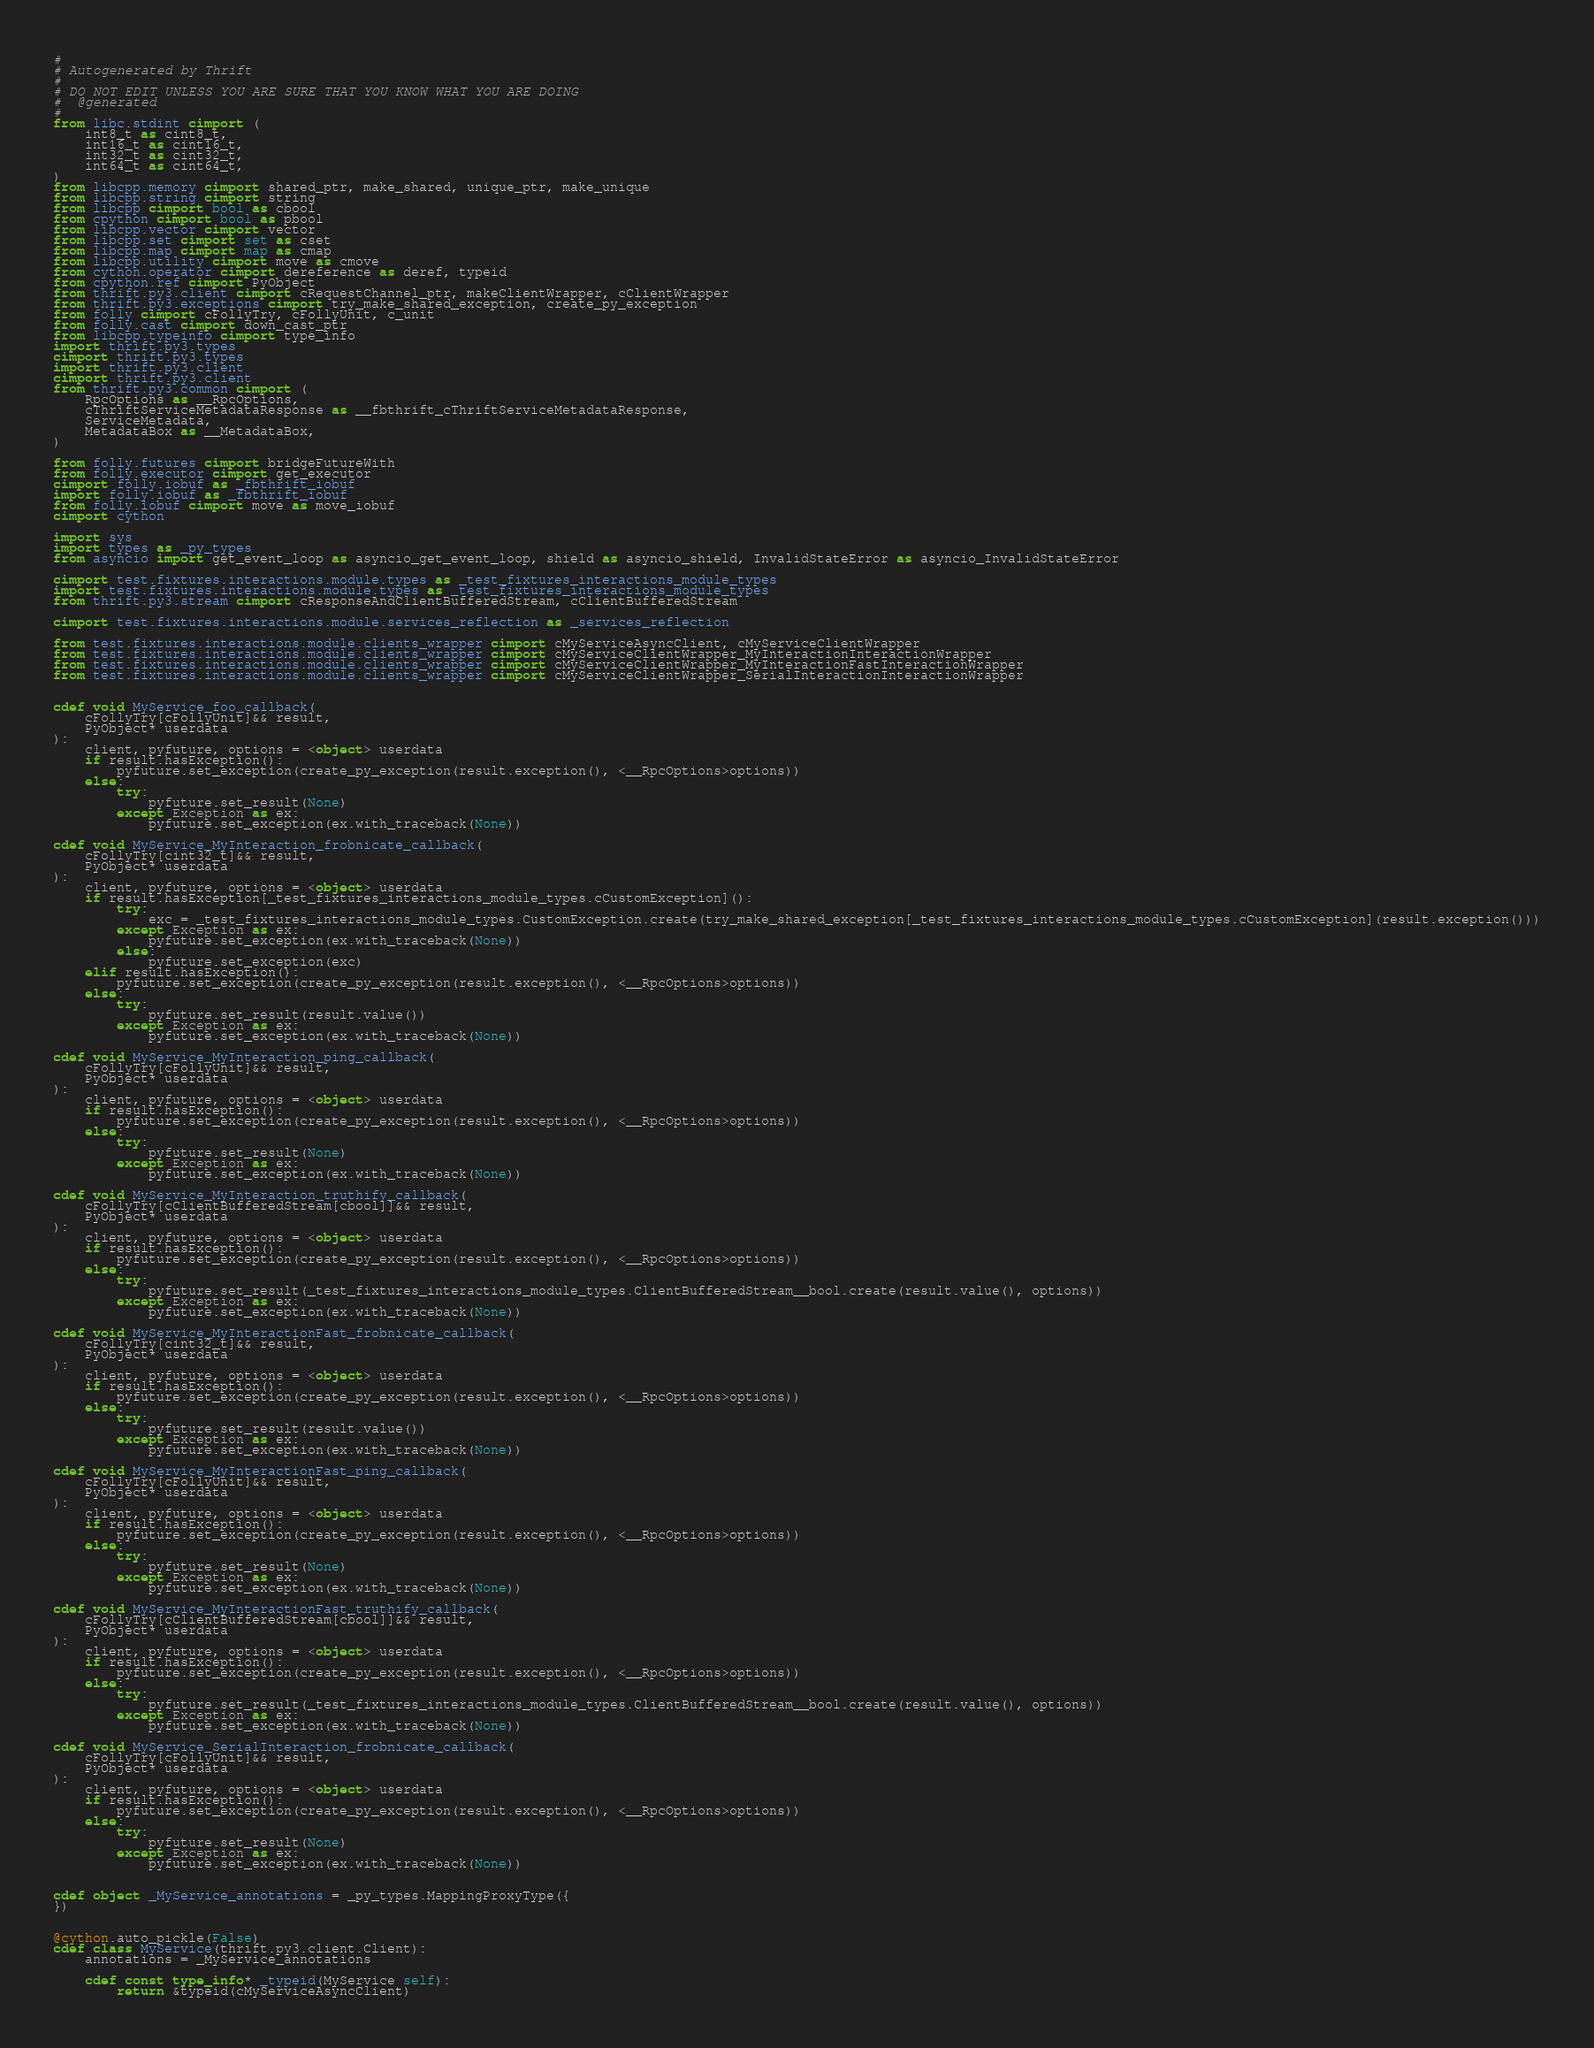<code> <loc_0><loc_0><loc_500><loc_500><_Cython_>#
# Autogenerated by Thrift
#
# DO NOT EDIT UNLESS YOU ARE SURE THAT YOU KNOW WHAT YOU ARE DOING
#  @generated
#
from libc.stdint cimport (
    int8_t as cint8_t,
    int16_t as cint16_t,
    int32_t as cint32_t,
    int64_t as cint64_t,
)
from libcpp.memory cimport shared_ptr, make_shared, unique_ptr, make_unique
from libcpp.string cimport string
from libcpp cimport bool as cbool
from cpython cimport bool as pbool
from libcpp.vector cimport vector
from libcpp.set cimport set as cset
from libcpp.map cimport map as cmap
from libcpp.utility cimport move as cmove
from cython.operator cimport dereference as deref, typeid
from cpython.ref cimport PyObject
from thrift.py3.client cimport cRequestChannel_ptr, makeClientWrapper, cClientWrapper
from thrift.py3.exceptions cimport try_make_shared_exception, create_py_exception
from folly cimport cFollyTry, cFollyUnit, c_unit
from folly.cast cimport down_cast_ptr
from libcpp.typeinfo cimport type_info
import thrift.py3.types
cimport thrift.py3.types
import thrift.py3.client
cimport thrift.py3.client
from thrift.py3.common cimport (
    RpcOptions as __RpcOptions,
    cThriftServiceMetadataResponse as __fbthrift_cThriftServiceMetadataResponse,
    ServiceMetadata,
    MetadataBox as __MetadataBox,
)

from folly.futures cimport bridgeFutureWith
from folly.executor cimport get_executor
cimport folly.iobuf as _fbthrift_iobuf
import folly.iobuf as _fbthrift_iobuf
from folly.iobuf cimport move as move_iobuf
cimport cython

import sys
import types as _py_types
from asyncio import get_event_loop as asyncio_get_event_loop, shield as asyncio_shield, InvalidStateError as asyncio_InvalidStateError

cimport test.fixtures.interactions.module.types as _test_fixtures_interactions_module_types
import test.fixtures.interactions.module.types as _test_fixtures_interactions_module_types
from thrift.py3.stream cimport cResponseAndClientBufferedStream, cClientBufferedStream

cimport test.fixtures.interactions.module.services_reflection as _services_reflection

from test.fixtures.interactions.module.clients_wrapper cimport cMyServiceAsyncClient, cMyServiceClientWrapper
from test.fixtures.interactions.module.clients_wrapper cimport cMyServiceClientWrapper_MyInteractionInteractionWrapper
from test.fixtures.interactions.module.clients_wrapper cimport cMyServiceClientWrapper_MyInteractionFastInteractionWrapper
from test.fixtures.interactions.module.clients_wrapper cimport cMyServiceClientWrapper_SerialInteractionInteractionWrapper


cdef void MyService_foo_callback(
    cFollyTry[cFollyUnit]&& result,
    PyObject* userdata
):
    client, pyfuture, options = <object> userdata  
    if result.hasException():
        pyfuture.set_exception(create_py_exception(result.exception(), <__RpcOptions>options))
    else:
        try:
            pyfuture.set_result(None)
        except Exception as ex:
            pyfuture.set_exception(ex.with_traceback(None))

cdef void MyService_MyInteraction_frobnicate_callback(
    cFollyTry[cint32_t]&& result,
    PyObject* userdata
):
    client, pyfuture, options = <object> userdata  
    if result.hasException[_test_fixtures_interactions_module_types.cCustomException]():
        try:
            exc = _test_fixtures_interactions_module_types.CustomException.create(try_make_shared_exception[_test_fixtures_interactions_module_types.cCustomException](result.exception()))
        except Exception as ex:
            pyfuture.set_exception(ex.with_traceback(None))
        else:
            pyfuture.set_exception(exc)
    elif result.hasException():
        pyfuture.set_exception(create_py_exception(result.exception(), <__RpcOptions>options))
    else:
        try:
            pyfuture.set_result(result.value())
        except Exception as ex:
            pyfuture.set_exception(ex.with_traceback(None))

cdef void MyService_MyInteraction_ping_callback(
    cFollyTry[cFollyUnit]&& result,
    PyObject* userdata
):
    client, pyfuture, options = <object> userdata  
    if result.hasException():
        pyfuture.set_exception(create_py_exception(result.exception(), <__RpcOptions>options))
    else:
        try:
            pyfuture.set_result(None)
        except Exception as ex:
            pyfuture.set_exception(ex.with_traceback(None))

cdef void MyService_MyInteraction_truthify_callback(
    cFollyTry[cClientBufferedStream[cbool]]&& result,
    PyObject* userdata
):
    client, pyfuture, options = <object> userdata  
    if result.hasException():
        pyfuture.set_exception(create_py_exception(result.exception(), <__RpcOptions>options))
    else:
        try:
            pyfuture.set_result(_test_fixtures_interactions_module_types.ClientBufferedStream__bool.create(result.value(), options))
        except Exception as ex:
            pyfuture.set_exception(ex.with_traceback(None))

cdef void MyService_MyInteractionFast_frobnicate_callback(
    cFollyTry[cint32_t]&& result,
    PyObject* userdata
):
    client, pyfuture, options = <object> userdata  
    if result.hasException():
        pyfuture.set_exception(create_py_exception(result.exception(), <__RpcOptions>options))
    else:
        try:
            pyfuture.set_result(result.value())
        except Exception as ex:
            pyfuture.set_exception(ex.with_traceback(None))

cdef void MyService_MyInteractionFast_ping_callback(
    cFollyTry[cFollyUnit]&& result,
    PyObject* userdata
):
    client, pyfuture, options = <object> userdata  
    if result.hasException():
        pyfuture.set_exception(create_py_exception(result.exception(), <__RpcOptions>options))
    else:
        try:
            pyfuture.set_result(None)
        except Exception as ex:
            pyfuture.set_exception(ex.with_traceback(None))

cdef void MyService_MyInteractionFast_truthify_callback(
    cFollyTry[cClientBufferedStream[cbool]]&& result,
    PyObject* userdata
):
    client, pyfuture, options = <object> userdata  
    if result.hasException():
        pyfuture.set_exception(create_py_exception(result.exception(), <__RpcOptions>options))
    else:
        try:
            pyfuture.set_result(_test_fixtures_interactions_module_types.ClientBufferedStream__bool.create(result.value(), options))
        except Exception as ex:
            pyfuture.set_exception(ex.with_traceback(None))

cdef void MyService_SerialInteraction_frobnicate_callback(
    cFollyTry[cFollyUnit]&& result,
    PyObject* userdata
):
    client, pyfuture, options = <object> userdata  
    if result.hasException():
        pyfuture.set_exception(create_py_exception(result.exception(), <__RpcOptions>options))
    else:
        try:
            pyfuture.set_result(None)
        except Exception as ex:
            pyfuture.set_exception(ex.with_traceback(None))


cdef object _MyService_annotations = _py_types.MappingProxyType({
})


@cython.auto_pickle(False)
cdef class MyService(thrift.py3.client.Client):
    annotations = _MyService_annotations

    cdef const type_info* _typeid(MyService self):
        return &typeid(cMyServiceAsyncClient)
</code> 